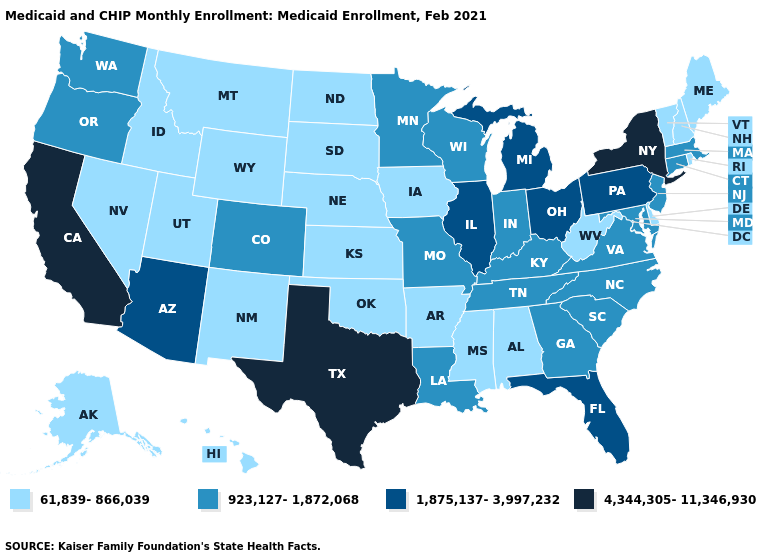What is the value of Utah?
Short answer required. 61,839-866,039. Does the first symbol in the legend represent the smallest category?
Give a very brief answer. Yes. What is the value of Hawaii?
Give a very brief answer. 61,839-866,039. Among the states that border Colorado , which have the highest value?
Answer briefly. Arizona. Name the states that have a value in the range 4,344,305-11,346,930?
Quick response, please. California, New York, Texas. What is the value of Oklahoma?
Give a very brief answer. 61,839-866,039. What is the value of Oregon?
Short answer required. 923,127-1,872,068. Name the states that have a value in the range 1,875,137-3,997,232?
Quick response, please. Arizona, Florida, Illinois, Michigan, Ohio, Pennsylvania. What is the highest value in states that border Virginia?
Be succinct. 923,127-1,872,068. How many symbols are there in the legend?
Quick response, please. 4. What is the value of Ohio?
Write a very short answer. 1,875,137-3,997,232. What is the lowest value in states that border Utah?
Keep it brief. 61,839-866,039. How many symbols are there in the legend?
Keep it brief. 4. What is the value of Wisconsin?
Quick response, please. 923,127-1,872,068. What is the value of Arkansas?
Short answer required. 61,839-866,039. 